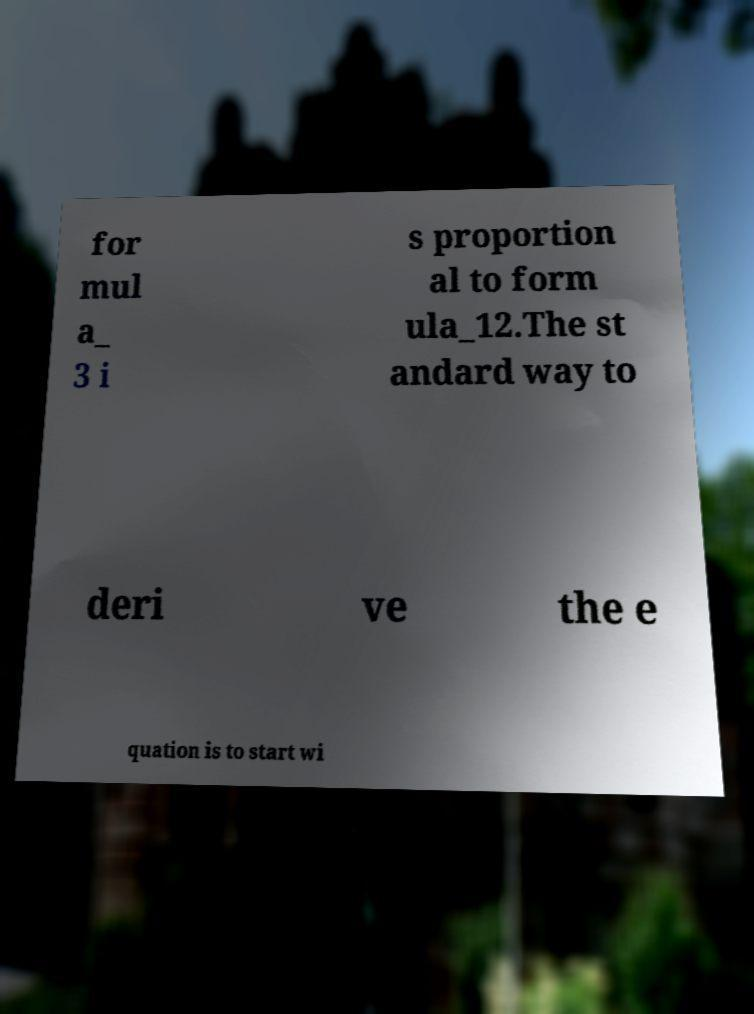Could you assist in decoding the text presented in this image and type it out clearly? for mul a_ 3 i s proportion al to form ula_12.The st andard way to deri ve the e quation is to start wi 